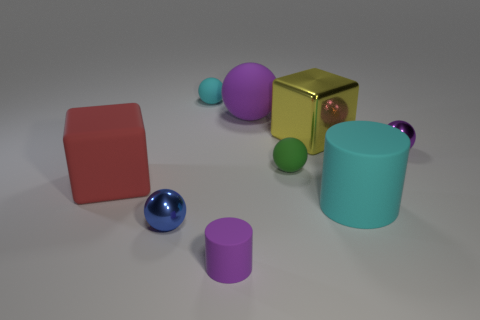How many purple spheres must be subtracted to get 1 purple spheres? 1 Add 1 small green rubber spheres. How many objects exist? 10 Subtract all big balls. How many balls are left? 4 Subtract all blue cubes. How many purple spheres are left? 2 Subtract all purple balls. How many balls are left? 3 Subtract 2 spheres. How many spheres are left? 3 Subtract all purple matte cylinders. Subtract all small purple objects. How many objects are left? 6 Add 1 red objects. How many red objects are left? 2 Add 6 large balls. How many large balls exist? 7 Subtract 1 cyan cylinders. How many objects are left? 8 